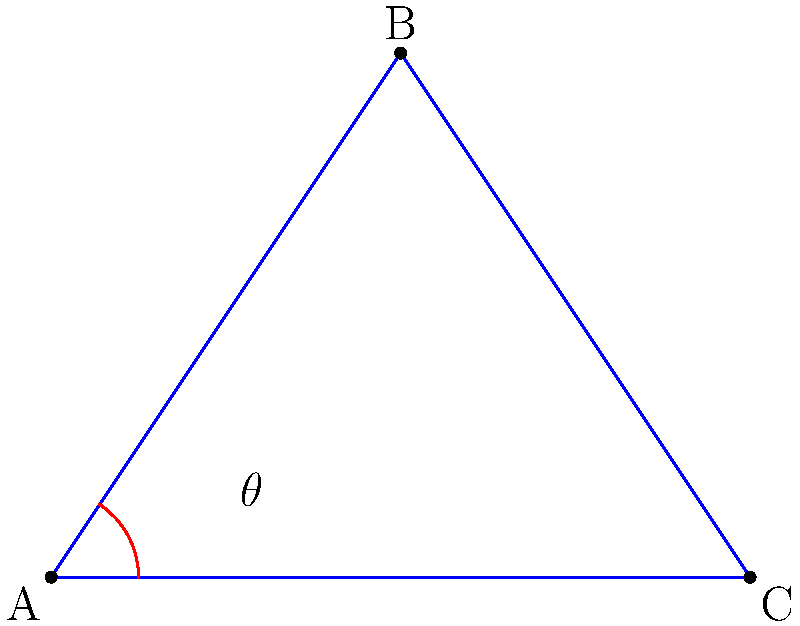In the context of analyzing joint angles during a walking movement, consider the stick figure diagram representing a leg. Point A represents the hip joint, B the knee joint, and C the ankle joint. If the angle $\theta$ at the hip joint (angle BAC) is 45°, what is the angle at the knee joint (angle ABC) in degrees? Assume the leg is in mid-stride position. To solve this problem, we'll follow these steps:

1. Recognize that the diagram represents a triangle ABC, where:
   - A is the hip joint
   - B is the knee joint
   - C is the ankle joint

2. Recall that the sum of angles in a triangle is always 180°.

3. We're given that angle BAC (θ) is 45°.

4. In a typical walking stride, the leg is not fully extended. Let's assume the ankle angle (BCA) is approximately 90° in mid-stride.

5. Using the triangle angle sum theorem:
   $$ \angle BAC + \angle ABC + \angle BCA = 180° $$

6. Substituting the known values:
   $$ 45° + \angle ABC + 90° = 180° $$

7. Solving for angle ABC:
   $$ \angle ABC = 180° - 45° - 90° = 45° $$

8. Therefore, the angle at the knee joint (ABC) is 45°.

This analysis aligns with typical biomechanical observations during walking, where the knee and hip angles often mirror each other in mid-stride. As a technology strategist, understanding these biomechanical principles can be crucial when developing or implementing motion analysis systems or health-related applications.
Answer: 45° 